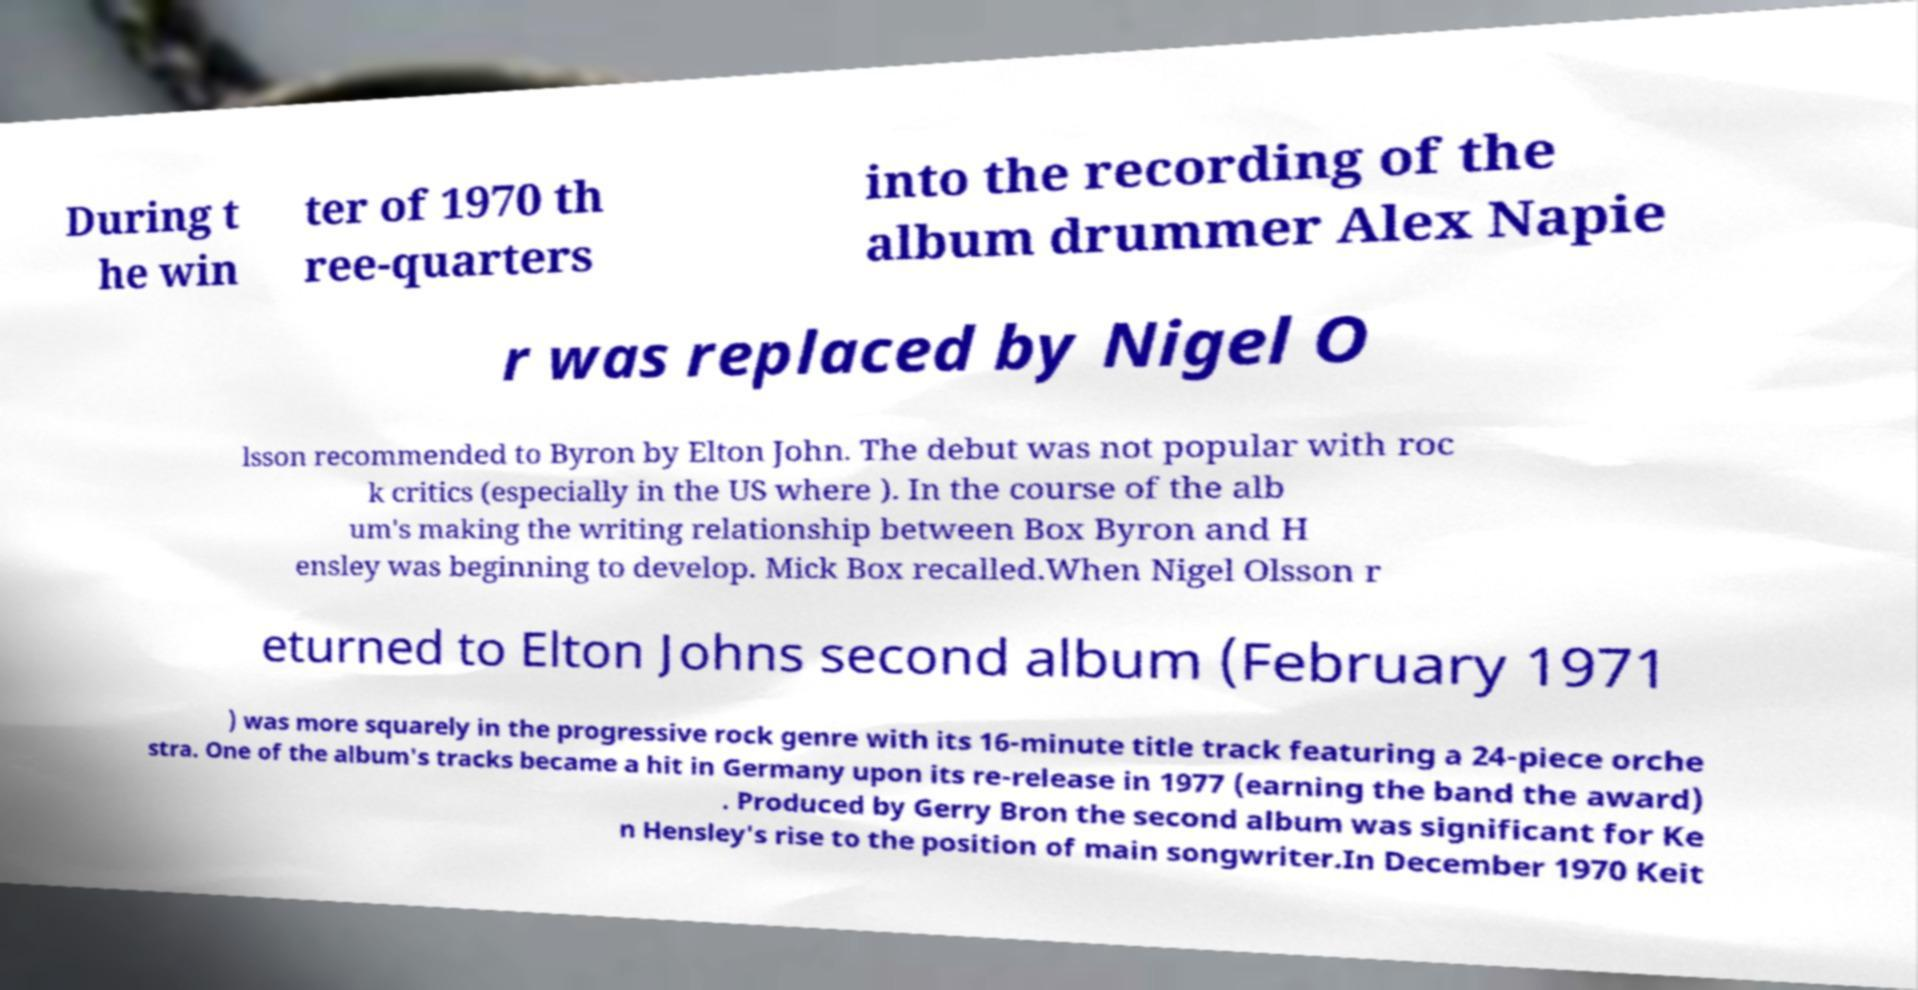For documentation purposes, I need the text within this image transcribed. Could you provide that? During t he win ter of 1970 th ree-quarters into the recording of the album drummer Alex Napie r was replaced by Nigel O lsson recommended to Byron by Elton John. The debut was not popular with roc k critics (especially in the US where ). In the course of the alb um's making the writing relationship between Box Byron and H ensley was beginning to develop. Mick Box recalled.When Nigel Olsson r eturned to Elton Johns second album (February 1971 ) was more squarely in the progressive rock genre with its 16-minute title track featuring a 24-piece orche stra. One of the album's tracks became a hit in Germany upon its re-release in 1977 (earning the band the award) . Produced by Gerry Bron the second album was significant for Ke n Hensley's rise to the position of main songwriter.In December 1970 Keit 